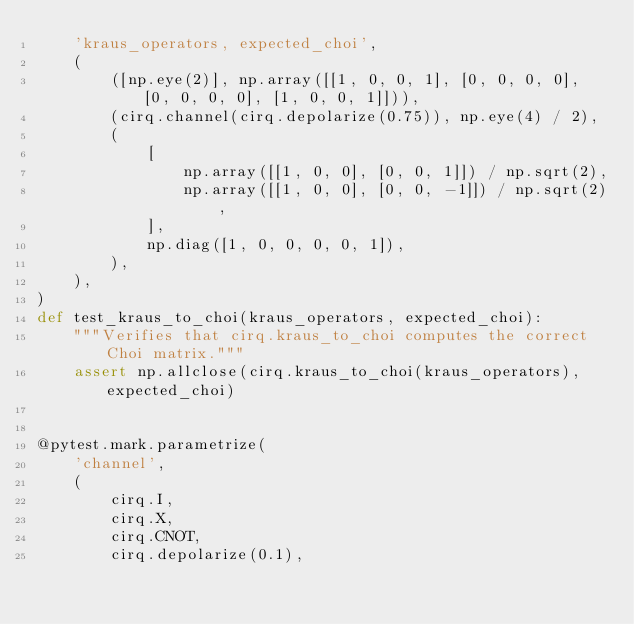<code> <loc_0><loc_0><loc_500><loc_500><_Python_>    'kraus_operators, expected_choi',
    (
        ([np.eye(2)], np.array([[1, 0, 0, 1], [0, 0, 0, 0], [0, 0, 0, 0], [1, 0, 0, 1]])),
        (cirq.channel(cirq.depolarize(0.75)), np.eye(4) / 2),
        (
            [
                np.array([[1, 0, 0], [0, 0, 1]]) / np.sqrt(2),
                np.array([[1, 0, 0], [0, 0, -1]]) / np.sqrt(2),
            ],
            np.diag([1, 0, 0, 0, 0, 1]),
        ),
    ),
)
def test_kraus_to_choi(kraus_operators, expected_choi):
    """Verifies that cirq.kraus_to_choi computes the correct Choi matrix."""
    assert np.allclose(cirq.kraus_to_choi(kraus_operators), expected_choi)


@pytest.mark.parametrize(
    'channel',
    (
        cirq.I,
        cirq.X,
        cirq.CNOT,
        cirq.depolarize(0.1),</code> 